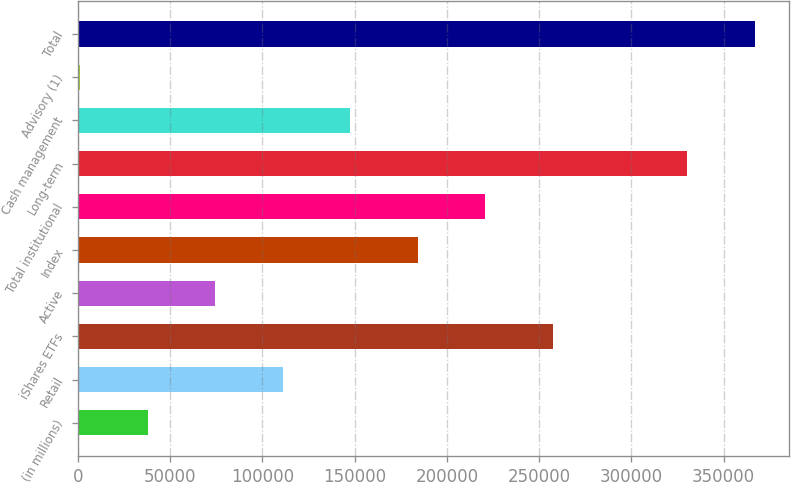Convert chart to OTSL. <chart><loc_0><loc_0><loc_500><loc_500><bar_chart><fcel>(in millions)<fcel>Retail<fcel>iShares ETFs<fcel>Active<fcel>Index<fcel>Total institutional<fcel>Long-term<fcel>Cash management<fcel>Advisory (1)<fcel>Total<nl><fcel>37845.9<fcel>111048<fcel>257451<fcel>74446.8<fcel>184250<fcel>220850<fcel>330240<fcel>147649<fcel>1245<fcel>367254<nl></chart> 